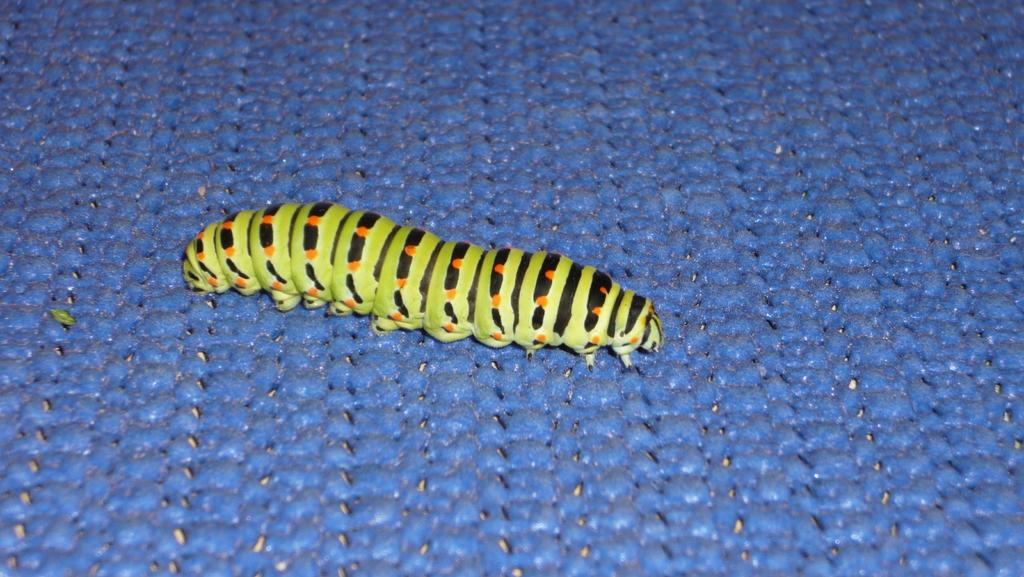What type of animal is in the image? There is a caterpillar in the image. What is the caterpillar resting on? The caterpillar is on a blue object. What type of bird is singing to the caterpillar in the image? There is no bird present in the image, and the caterpillar is not interacting with any other animals. 